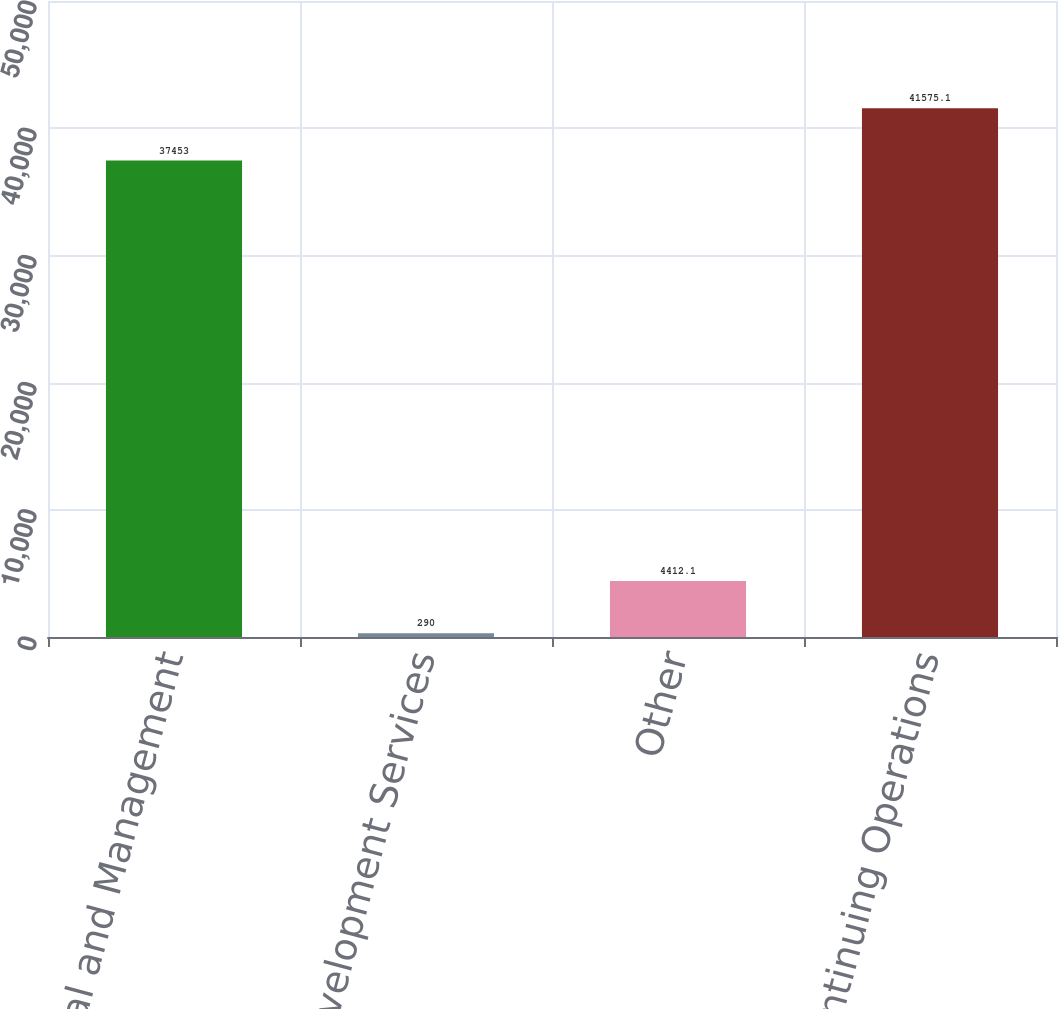<chart> <loc_0><loc_0><loc_500><loc_500><bar_chart><fcel>Rental and Management<fcel>Network Development Services<fcel>Other<fcel>Continuing Operations<nl><fcel>37453<fcel>290<fcel>4412.1<fcel>41575.1<nl></chart> 